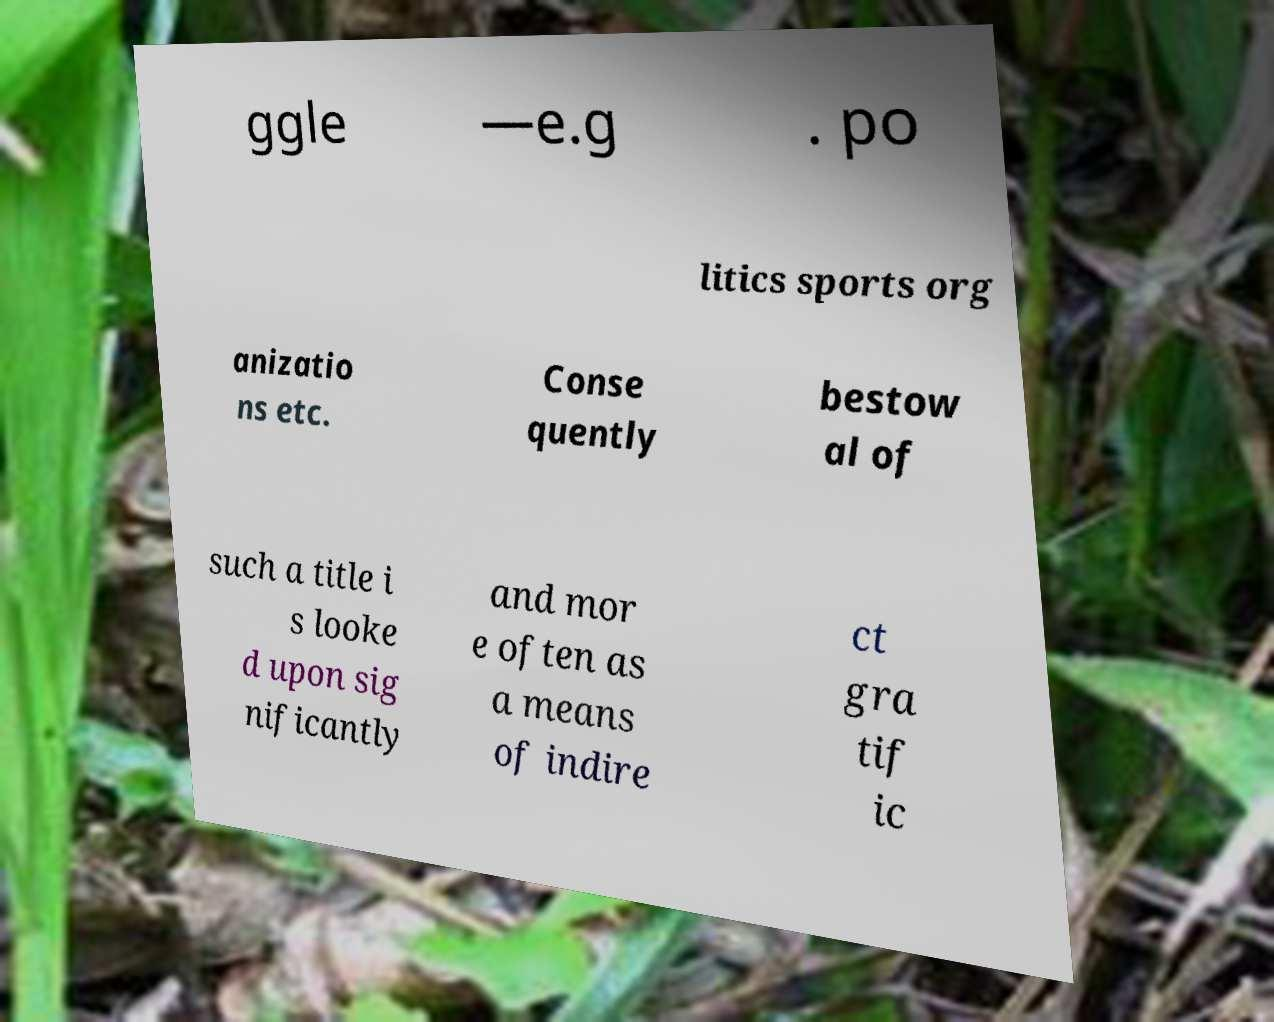Could you extract and type out the text from this image? ggle —e.g . po litics sports org anizatio ns etc. Conse quently bestow al of such a title i s looke d upon sig nificantly and mor e often as a means of indire ct gra tif ic 